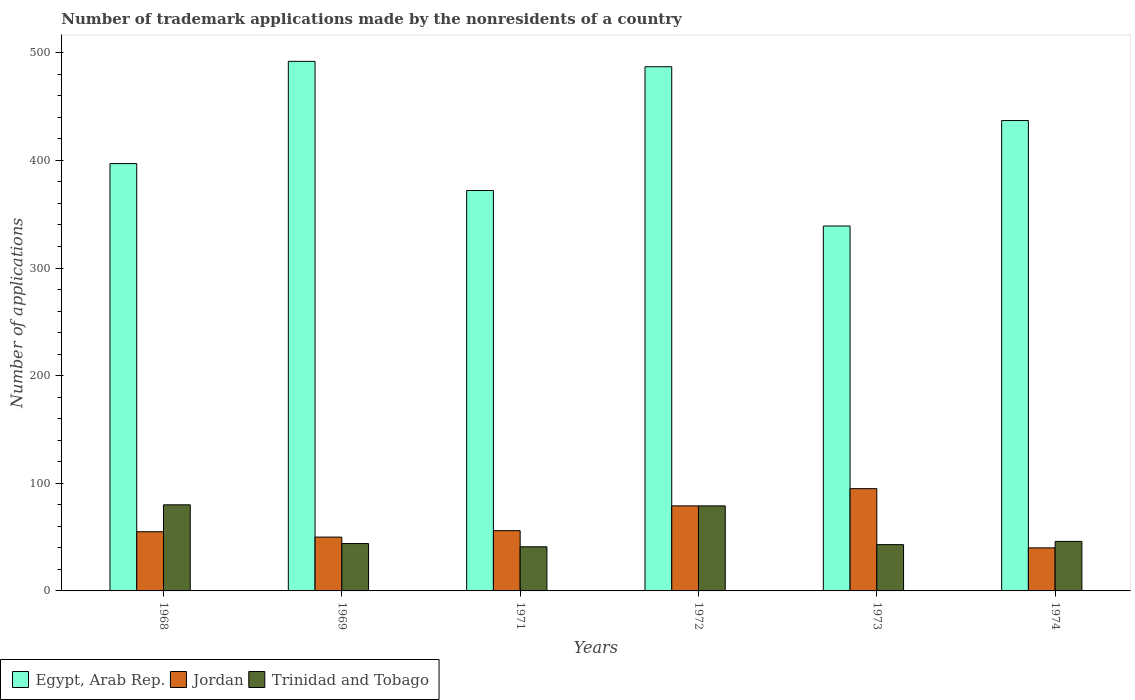How many groups of bars are there?
Provide a succinct answer. 6. How many bars are there on the 1st tick from the left?
Your answer should be very brief. 3. How many bars are there on the 4th tick from the right?
Keep it short and to the point. 3. What is the label of the 2nd group of bars from the left?
Provide a short and direct response. 1969. What is the number of trademark applications made by the nonresidents in Egypt, Arab Rep. in 1969?
Offer a terse response. 492. In which year was the number of trademark applications made by the nonresidents in Trinidad and Tobago maximum?
Provide a short and direct response. 1968. In which year was the number of trademark applications made by the nonresidents in Egypt, Arab Rep. minimum?
Give a very brief answer. 1973. What is the total number of trademark applications made by the nonresidents in Jordan in the graph?
Provide a short and direct response. 375. What is the difference between the number of trademark applications made by the nonresidents in Egypt, Arab Rep. in 1969 and that in 1974?
Your answer should be very brief. 55. What is the difference between the number of trademark applications made by the nonresidents in Trinidad and Tobago in 1973 and the number of trademark applications made by the nonresidents in Egypt, Arab Rep. in 1972?
Keep it short and to the point. -444. What is the average number of trademark applications made by the nonresidents in Egypt, Arab Rep. per year?
Give a very brief answer. 420.67. In the year 1971, what is the difference between the number of trademark applications made by the nonresidents in Trinidad and Tobago and number of trademark applications made by the nonresidents in Egypt, Arab Rep.?
Make the answer very short. -331. Is the number of trademark applications made by the nonresidents in Jordan in 1971 less than that in 1972?
Keep it short and to the point. Yes. What is the difference between the highest and the lowest number of trademark applications made by the nonresidents in Trinidad and Tobago?
Offer a terse response. 39. What does the 2nd bar from the left in 1968 represents?
Offer a very short reply. Jordan. What does the 2nd bar from the right in 1972 represents?
Keep it short and to the point. Jordan. Is it the case that in every year, the sum of the number of trademark applications made by the nonresidents in Trinidad and Tobago and number of trademark applications made by the nonresidents in Egypt, Arab Rep. is greater than the number of trademark applications made by the nonresidents in Jordan?
Give a very brief answer. Yes. Are all the bars in the graph horizontal?
Offer a very short reply. No. Does the graph contain any zero values?
Provide a succinct answer. No. Where does the legend appear in the graph?
Your answer should be very brief. Bottom left. How are the legend labels stacked?
Give a very brief answer. Horizontal. What is the title of the graph?
Offer a very short reply. Number of trademark applications made by the nonresidents of a country. Does "Yemen, Rep." appear as one of the legend labels in the graph?
Your response must be concise. No. What is the label or title of the Y-axis?
Make the answer very short. Number of applications. What is the Number of applications of Egypt, Arab Rep. in 1968?
Provide a short and direct response. 397. What is the Number of applications in Egypt, Arab Rep. in 1969?
Keep it short and to the point. 492. What is the Number of applications in Trinidad and Tobago in 1969?
Provide a short and direct response. 44. What is the Number of applications of Egypt, Arab Rep. in 1971?
Make the answer very short. 372. What is the Number of applications in Jordan in 1971?
Provide a short and direct response. 56. What is the Number of applications in Egypt, Arab Rep. in 1972?
Provide a short and direct response. 487. What is the Number of applications in Jordan in 1972?
Offer a very short reply. 79. What is the Number of applications in Trinidad and Tobago in 1972?
Offer a very short reply. 79. What is the Number of applications in Egypt, Arab Rep. in 1973?
Keep it short and to the point. 339. What is the Number of applications of Trinidad and Tobago in 1973?
Your response must be concise. 43. What is the Number of applications of Egypt, Arab Rep. in 1974?
Offer a terse response. 437. What is the Number of applications of Jordan in 1974?
Provide a short and direct response. 40. Across all years, what is the maximum Number of applications of Egypt, Arab Rep.?
Provide a succinct answer. 492. Across all years, what is the maximum Number of applications in Trinidad and Tobago?
Provide a short and direct response. 80. Across all years, what is the minimum Number of applications of Egypt, Arab Rep.?
Give a very brief answer. 339. Across all years, what is the minimum Number of applications of Jordan?
Provide a succinct answer. 40. What is the total Number of applications of Egypt, Arab Rep. in the graph?
Make the answer very short. 2524. What is the total Number of applications of Jordan in the graph?
Your answer should be very brief. 375. What is the total Number of applications in Trinidad and Tobago in the graph?
Keep it short and to the point. 333. What is the difference between the Number of applications in Egypt, Arab Rep. in 1968 and that in 1969?
Your response must be concise. -95. What is the difference between the Number of applications of Jordan in 1968 and that in 1969?
Offer a terse response. 5. What is the difference between the Number of applications of Trinidad and Tobago in 1968 and that in 1969?
Your answer should be compact. 36. What is the difference between the Number of applications in Egypt, Arab Rep. in 1968 and that in 1971?
Keep it short and to the point. 25. What is the difference between the Number of applications of Jordan in 1968 and that in 1971?
Provide a succinct answer. -1. What is the difference between the Number of applications in Egypt, Arab Rep. in 1968 and that in 1972?
Give a very brief answer. -90. What is the difference between the Number of applications of Jordan in 1968 and that in 1972?
Ensure brevity in your answer.  -24. What is the difference between the Number of applications of Trinidad and Tobago in 1968 and that in 1973?
Your answer should be compact. 37. What is the difference between the Number of applications of Egypt, Arab Rep. in 1968 and that in 1974?
Your answer should be compact. -40. What is the difference between the Number of applications of Trinidad and Tobago in 1968 and that in 1974?
Offer a very short reply. 34. What is the difference between the Number of applications in Egypt, Arab Rep. in 1969 and that in 1971?
Give a very brief answer. 120. What is the difference between the Number of applications of Trinidad and Tobago in 1969 and that in 1971?
Offer a terse response. 3. What is the difference between the Number of applications of Trinidad and Tobago in 1969 and that in 1972?
Offer a very short reply. -35. What is the difference between the Number of applications in Egypt, Arab Rep. in 1969 and that in 1973?
Give a very brief answer. 153. What is the difference between the Number of applications of Jordan in 1969 and that in 1973?
Your answer should be compact. -45. What is the difference between the Number of applications in Trinidad and Tobago in 1969 and that in 1973?
Your answer should be compact. 1. What is the difference between the Number of applications of Egypt, Arab Rep. in 1969 and that in 1974?
Provide a short and direct response. 55. What is the difference between the Number of applications in Trinidad and Tobago in 1969 and that in 1974?
Give a very brief answer. -2. What is the difference between the Number of applications in Egypt, Arab Rep. in 1971 and that in 1972?
Keep it short and to the point. -115. What is the difference between the Number of applications in Trinidad and Tobago in 1971 and that in 1972?
Provide a short and direct response. -38. What is the difference between the Number of applications in Egypt, Arab Rep. in 1971 and that in 1973?
Your answer should be compact. 33. What is the difference between the Number of applications of Jordan in 1971 and that in 1973?
Your response must be concise. -39. What is the difference between the Number of applications of Trinidad and Tobago in 1971 and that in 1973?
Give a very brief answer. -2. What is the difference between the Number of applications in Egypt, Arab Rep. in 1971 and that in 1974?
Your response must be concise. -65. What is the difference between the Number of applications of Jordan in 1971 and that in 1974?
Offer a very short reply. 16. What is the difference between the Number of applications of Trinidad and Tobago in 1971 and that in 1974?
Provide a succinct answer. -5. What is the difference between the Number of applications in Egypt, Arab Rep. in 1972 and that in 1973?
Your answer should be compact. 148. What is the difference between the Number of applications of Jordan in 1972 and that in 1973?
Offer a very short reply. -16. What is the difference between the Number of applications of Egypt, Arab Rep. in 1972 and that in 1974?
Give a very brief answer. 50. What is the difference between the Number of applications in Egypt, Arab Rep. in 1973 and that in 1974?
Your response must be concise. -98. What is the difference between the Number of applications in Egypt, Arab Rep. in 1968 and the Number of applications in Jordan in 1969?
Your response must be concise. 347. What is the difference between the Number of applications in Egypt, Arab Rep. in 1968 and the Number of applications in Trinidad and Tobago in 1969?
Your answer should be compact. 353. What is the difference between the Number of applications of Egypt, Arab Rep. in 1968 and the Number of applications of Jordan in 1971?
Provide a succinct answer. 341. What is the difference between the Number of applications of Egypt, Arab Rep. in 1968 and the Number of applications of Trinidad and Tobago in 1971?
Your response must be concise. 356. What is the difference between the Number of applications in Egypt, Arab Rep. in 1968 and the Number of applications in Jordan in 1972?
Your response must be concise. 318. What is the difference between the Number of applications in Egypt, Arab Rep. in 1968 and the Number of applications in Trinidad and Tobago in 1972?
Your answer should be compact. 318. What is the difference between the Number of applications of Jordan in 1968 and the Number of applications of Trinidad and Tobago in 1972?
Offer a terse response. -24. What is the difference between the Number of applications of Egypt, Arab Rep. in 1968 and the Number of applications of Jordan in 1973?
Ensure brevity in your answer.  302. What is the difference between the Number of applications of Egypt, Arab Rep. in 1968 and the Number of applications of Trinidad and Tobago in 1973?
Your answer should be compact. 354. What is the difference between the Number of applications of Egypt, Arab Rep. in 1968 and the Number of applications of Jordan in 1974?
Provide a short and direct response. 357. What is the difference between the Number of applications in Egypt, Arab Rep. in 1968 and the Number of applications in Trinidad and Tobago in 1974?
Give a very brief answer. 351. What is the difference between the Number of applications in Egypt, Arab Rep. in 1969 and the Number of applications in Jordan in 1971?
Keep it short and to the point. 436. What is the difference between the Number of applications of Egypt, Arab Rep. in 1969 and the Number of applications of Trinidad and Tobago in 1971?
Keep it short and to the point. 451. What is the difference between the Number of applications in Egypt, Arab Rep. in 1969 and the Number of applications in Jordan in 1972?
Offer a very short reply. 413. What is the difference between the Number of applications in Egypt, Arab Rep. in 1969 and the Number of applications in Trinidad and Tobago in 1972?
Ensure brevity in your answer.  413. What is the difference between the Number of applications in Jordan in 1969 and the Number of applications in Trinidad and Tobago in 1972?
Your answer should be compact. -29. What is the difference between the Number of applications in Egypt, Arab Rep. in 1969 and the Number of applications in Jordan in 1973?
Provide a succinct answer. 397. What is the difference between the Number of applications in Egypt, Arab Rep. in 1969 and the Number of applications in Trinidad and Tobago in 1973?
Keep it short and to the point. 449. What is the difference between the Number of applications in Egypt, Arab Rep. in 1969 and the Number of applications in Jordan in 1974?
Make the answer very short. 452. What is the difference between the Number of applications in Egypt, Arab Rep. in 1969 and the Number of applications in Trinidad and Tobago in 1974?
Keep it short and to the point. 446. What is the difference between the Number of applications of Jordan in 1969 and the Number of applications of Trinidad and Tobago in 1974?
Your answer should be very brief. 4. What is the difference between the Number of applications of Egypt, Arab Rep. in 1971 and the Number of applications of Jordan in 1972?
Make the answer very short. 293. What is the difference between the Number of applications in Egypt, Arab Rep. in 1971 and the Number of applications in Trinidad and Tobago in 1972?
Your response must be concise. 293. What is the difference between the Number of applications in Egypt, Arab Rep. in 1971 and the Number of applications in Jordan in 1973?
Ensure brevity in your answer.  277. What is the difference between the Number of applications in Egypt, Arab Rep. in 1971 and the Number of applications in Trinidad and Tobago in 1973?
Keep it short and to the point. 329. What is the difference between the Number of applications of Jordan in 1971 and the Number of applications of Trinidad and Tobago in 1973?
Your answer should be very brief. 13. What is the difference between the Number of applications in Egypt, Arab Rep. in 1971 and the Number of applications in Jordan in 1974?
Your answer should be very brief. 332. What is the difference between the Number of applications in Egypt, Arab Rep. in 1971 and the Number of applications in Trinidad and Tobago in 1974?
Ensure brevity in your answer.  326. What is the difference between the Number of applications in Egypt, Arab Rep. in 1972 and the Number of applications in Jordan in 1973?
Keep it short and to the point. 392. What is the difference between the Number of applications in Egypt, Arab Rep. in 1972 and the Number of applications in Trinidad and Tobago in 1973?
Your answer should be compact. 444. What is the difference between the Number of applications of Jordan in 1972 and the Number of applications of Trinidad and Tobago in 1973?
Your answer should be very brief. 36. What is the difference between the Number of applications of Egypt, Arab Rep. in 1972 and the Number of applications of Jordan in 1974?
Your response must be concise. 447. What is the difference between the Number of applications in Egypt, Arab Rep. in 1972 and the Number of applications in Trinidad and Tobago in 1974?
Make the answer very short. 441. What is the difference between the Number of applications of Egypt, Arab Rep. in 1973 and the Number of applications of Jordan in 1974?
Offer a terse response. 299. What is the difference between the Number of applications of Egypt, Arab Rep. in 1973 and the Number of applications of Trinidad and Tobago in 1974?
Your answer should be very brief. 293. What is the difference between the Number of applications of Jordan in 1973 and the Number of applications of Trinidad and Tobago in 1974?
Your answer should be very brief. 49. What is the average Number of applications in Egypt, Arab Rep. per year?
Offer a very short reply. 420.67. What is the average Number of applications in Jordan per year?
Ensure brevity in your answer.  62.5. What is the average Number of applications of Trinidad and Tobago per year?
Give a very brief answer. 55.5. In the year 1968, what is the difference between the Number of applications in Egypt, Arab Rep. and Number of applications in Jordan?
Offer a very short reply. 342. In the year 1968, what is the difference between the Number of applications in Egypt, Arab Rep. and Number of applications in Trinidad and Tobago?
Provide a succinct answer. 317. In the year 1968, what is the difference between the Number of applications in Jordan and Number of applications in Trinidad and Tobago?
Your answer should be compact. -25. In the year 1969, what is the difference between the Number of applications in Egypt, Arab Rep. and Number of applications in Jordan?
Offer a terse response. 442. In the year 1969, what is the difference between the Number of applications in Egypt, Arab Rep. and Number of applications in Trinidad and Tobago?
Make the answer very short. 448. In the year 1971, what is the difference between the Number of applications in Egypt, Arab Rep. and Number of applications in Jordan?
Offer a very short reply. 316. In the year 1971, what is the difference between the Number of applications of Egypt, Arab Rep. and Number of applications of Trinidad and Tobago?
Your answer should be very brief. 331. In the year 1972, what is the difference between the Number of applications of Egypt, Arab Rep. and Number of applications of Jordan?
Keep it short and to the point. 408. In the year 1972, what is the difference between the Number of applications of Egypt, Arab Rep. and Number of applications of Trinidad and Tobago?
Your answer should be very brief. 408. In the year 1973, what is the difference between the Number of applications of Egypt, Arab Rep. and Number of applications of Jordan?
Your response must be concise. 244. In the year 1973, what is the difference between the Number of applications in Egypt, Arab Rep. and Number of applications in Trinidad and Tobago?
Make the answer very short. 296. In the year 1974, what is the difference between the Number of applications of Egypt, Arab Rep. and Number of applications of Jordan?
Provide a short and direct response. 397. In the year 1974, what is the difference between the Number of applications in Egypt, Arab Rep. and Number of applications in Trinidad and Tobago?
Your response must be concise. 391. What is the ratio of the Number of applications of Egypt, Arab Rep. in 1968 to that in 1969?
Your answer should be compact. 0.81. What is the ratio of the Number of applications of Trinidad and Tobago in 1968 to that in 1969?
Make the answer very short. 1.82. What is the ratio of the Number of applications of Egypt, Arab Rep. in 1968 to that in 1971?
Make the answer very short. 1.07. What is the ratio of the Number of applications in Jordan in 1968 to that in 1971?
Provide a short and direct response. 0.98. What is the ratio of the Number of applications of Trinidad and Tobago in 1968 to that in 1971?
Ensure brevity in your answer.  1.95. What is the ratio of the Number of applications of Egypt, Arab Rep. in 1968 to that in 1972?
Ensure brevity in your answer.  0.82. What is the ratio of the Number of applications in Jordan in 1968 to that in 1972?
Provide a short and direct response. 0.7. What is the ratio of the Number of applications in Trinidad and Tobago in 1968 to that in 1972?
Offer a very short reply. 1.01. What is the ratio of the Number of applications in Egypt, Arab Rep. in 1968 to that in 1973?
Provide a short and direct response. 1.17. What is the ratio of the Number of applications of Jordan in 1968 to that in 1973?
Provide a succinct answer. 0.58. What is the ratio of the Number of applications in Trinidad and Tobago in 1968 to that in 1973?
Give a very brief answer. 1.86. What is the ratio of the Number of applications in Egypt, Arab Rep. in 1968 to that in 1974?
Your response must be concise. 0.91. What is the ratio of the Number of applications in Jordan in 1968 to that in 1974?
Provide a succinct answer. 1.38. What is the ratio of the Number of applications of Trinidad and Tobago in 1968 to that in 1974?
Your answer should be very brief. 1.74. What is the ratio of the Number of applications in Egypt, Arab Rep. in 1969 to that in 1971?
Give a very brief answer. 1.32. What is the ratio of the Number of applications in Jordan in 1969 to that in 1971?
Make the answer very short. 0.89. What is the ratio of the Number of applications in Trinidad and Tobago in 1969 to that in 1971?
Your response must be concise. 1.07. What is the ratio of the Number of applications of Egypt, Arab Rep. in 1969 to that in 1972?
Offer a terse response. 1.01. What is the ratio of the Number of applications in Jordan in 1969 to that in 1972?
Your response must be concise. 0.63. What is the ratio of the Number of applications of Trinidad and Tobago in 1969 to that in 1972?
Offer a very short reply. 0.56. What is the ratio of the Number of applications in Egypt, Arab Rep. in 1969 to that in 1973?
Keep it short and to the point. 1.45. What is the ratio of the Number of applications of Jordan in 1969 to that in 1973?
Make the answer very short. 0.53. What is the ratio of the Number of applications of Trinidad and Tobago in 1969 to that in 1973?
Your answer should be compact. 1.02. What is the ratio of the Number of applications of Egypt, Arab Rep. in 1969 to that in 1974?
Your answer should be very brief. 1.13. What is the ratio of the Number of applications of Jordan in 1969 to that in 1974?
Give a very brief answer. 1.25. What is the ratio of the Number of applications of Trinidad and Tobago in 1969 to that in 1974?
Give a very brief answer. 0.96. What is the ratio of the Number of applications of Egypt, Arab Rep. in 1971 to that in 1972?
Provide a succinct answer. 0.76. What is the ratio of the Number of applications of Jordan in 1971 to that in 1972?
Your answer should be very brief. 0.71. What is the ratio of the Number of applications in Trinidad and Tobago in 1971 to that in 1972?
Offer a very short reply. 0.52. What is the ratio of the Number of applications of Egypt, Arab Rep. in 1971 to that in 1973?
Offer a very short reply. 1.1. What is the ratio of the Number of applications of Jordan in 1971 to that in 1973?
Your response must be concise. 0.59. What is the ratio of the Number of applications in Trinidad and Tobago in 1971 to that in 1973?
Give a very brief answer. 0.95. What is the ratio of the Number of applications in Egypt, Arab Rep. in 1971 to that in 1974?
Your response must be concise. 0.85. What is the ratio of the Number of applications in Jordan in 1971 to that in 1974?
Your response must be concise. 1.4. What is the ratio of the Number of applications in Trinidad and Tobago in 1971 to that in 1974?
Make the answer very short. 0.89. What is the ratio of the Number of applications in Egypt, Arab Rep. in 1972 to that in 1973?
Your answer should be compact. 1.44. What is the ratio of the Number of applications of Jordan in 1972 to that in 1973?
Your response must be concise. 0.83. What is the ratio of the Number of applications of Trinidad and Tobago in 1972 to that in 1973?
Offer a terse response. 1.84. What is the ratio of the Number of applications in Egypt, Arab Rep. in 1972 to that in 1974?
Keep it short and to the point. 1.11. What is the ratio of the Number of applications of Jordan in 1972 to that in 1974?
Your answer should be compact. 1.98. What is the ratio of the Number of applications in Trinidad and Tobago in 1972 to that in 1974?
Offer a terse response. 1.72. What is the ratio of the Number of applications of Egypt, Arab Rep. in 1973 to that in 1974?
Offer a very short reply. 0.78. What is the ratio of the Number of applications of Jordan in 1973 to that in 1974?
Provide a short and direct response. 2.38. What is the ratio of the Number of applications of Trinidad and Tobago in 1973 to that in 1974?
Keep it short and to the point. 0.93. What is the difference between the highest and the second highest Number of applications in Jordan?
Your response must be concise. 16. What is the difference between the highest and the second highest Number of applications in Trinidad and Tobago?
Make the answer very short. 1. What is the difference between the highest and the lowest Number of applications in Egypt, Arab Rep.?
Provide a succinct answer. 153. What is the difference between the highest and the lowest Number of applications of Trinidad and Tobago?
Your response must be concise. 39. 